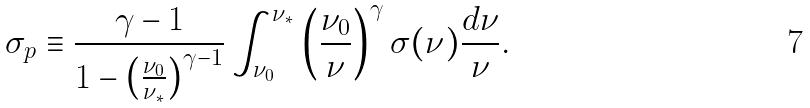Convert formula to latex. <formula><loc_0><loc_0><loc_500><loc_500>\sigma _ { p } \equiv \frac { \gamma - 1 } { 1 - \left ( \frac { \nu _ { 0 } } { \nu _ { \ast } } \right ) ^ { \gamma - 1 } } \int _ { \nu _ { 0 } } ^ { \nu _ { \ast } } \left ( \frac { \nu _ { 0 } } { \nu } \right ) ^ { \gamma } \sigma ( \nu ) \frac { d \nu } { \nu } .</formula> 